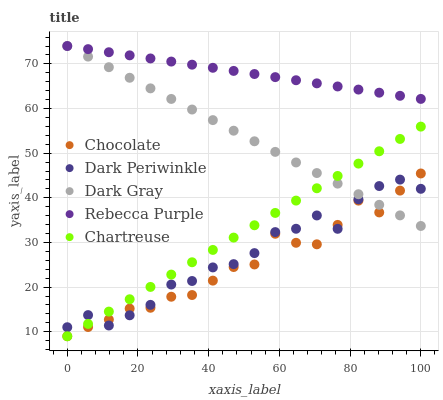Does Chocolate have the minimum area under the curve?
Answer yes or no. Yes. Does Rebecca Purple have the maximum area under the curve?
Answer yes or no. Yes. Does Chartreuse have the minimum area under the curve?
Answer yes or no. No. Does Chartreuse have the maximum area under the curve?
Answer yes or no. No. Is Chartreuse the smoothest?
Answer yes or no. Yes. Is Dark Periwinkle the roughest?
Answer yes or no. Yes. Is Dark Periwinkle the smoothest?
Answer yes or no. No. Is Chartreuse the roughest?
Answer yes or no. No. Does Chartreuse have the lowest value?
Answer yes or no. Yes. Does Dark Periwinkle have the lowest value?
Answer yes or no. No. Does Rebecca Purple have the highest value?
Answer yes or no. Yes. Does Chartreuse have the highest value?
Answer yes or no. No. Is Dark Periwinkle less than Rebecca Purple?
Answer yes or no. Yes. Is Rebecca Purple greater than Chartreuse?
Answer yes or no. Yes. Does Dark Gray intersect Chartreuse?
Answer yes or no. Yes. Is Dark Gray less than Chartreuse?
Answer yes or no. No. Is Dark Gray greater than Chartreuse?
Answer yes or no. No. Does Dark Periwinkle intersect Rebecca Purple?
Answer yes or no. No. 